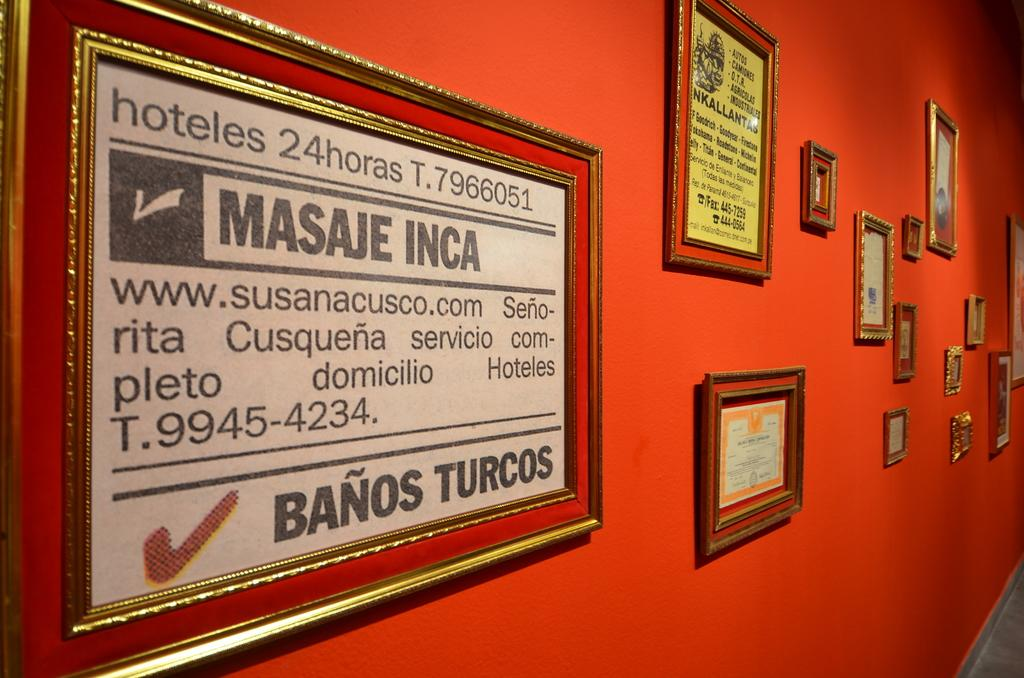Provide a one-sentence caption for the provided image. Several framed signs are on a wall, including one that says Masaje Inca. 